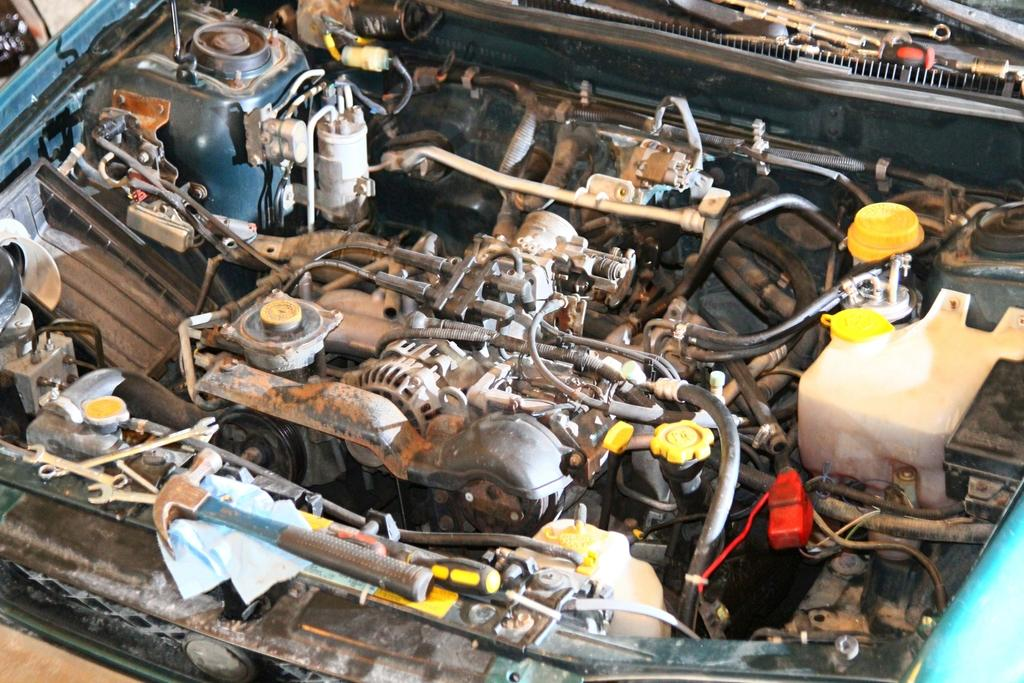What is the main subject of the image? The main subject of the image is an engine. What type of object might the engine be a part of? The engine appears to be a part of a vehicle. What kind of vehicle is the engine likely from? The vehicle is likely a car. What color is the thread used to decorate the bedroom in the image? There is no bedroom or thread present in the image; it features an engine that is likely a part of a car. 